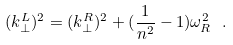<formula> <loc_0><loc_0><loc_500><loc_500>( k _ { \perp } ^ { L } ) ^ { 2 } = ( k _ { \perp } ^ { R } ) ^ { 2 } + ( \frac { 1 } { n ^ { 2 } } - 1 ) \omega _ { R } ^ { 2 } \ .</formula> 